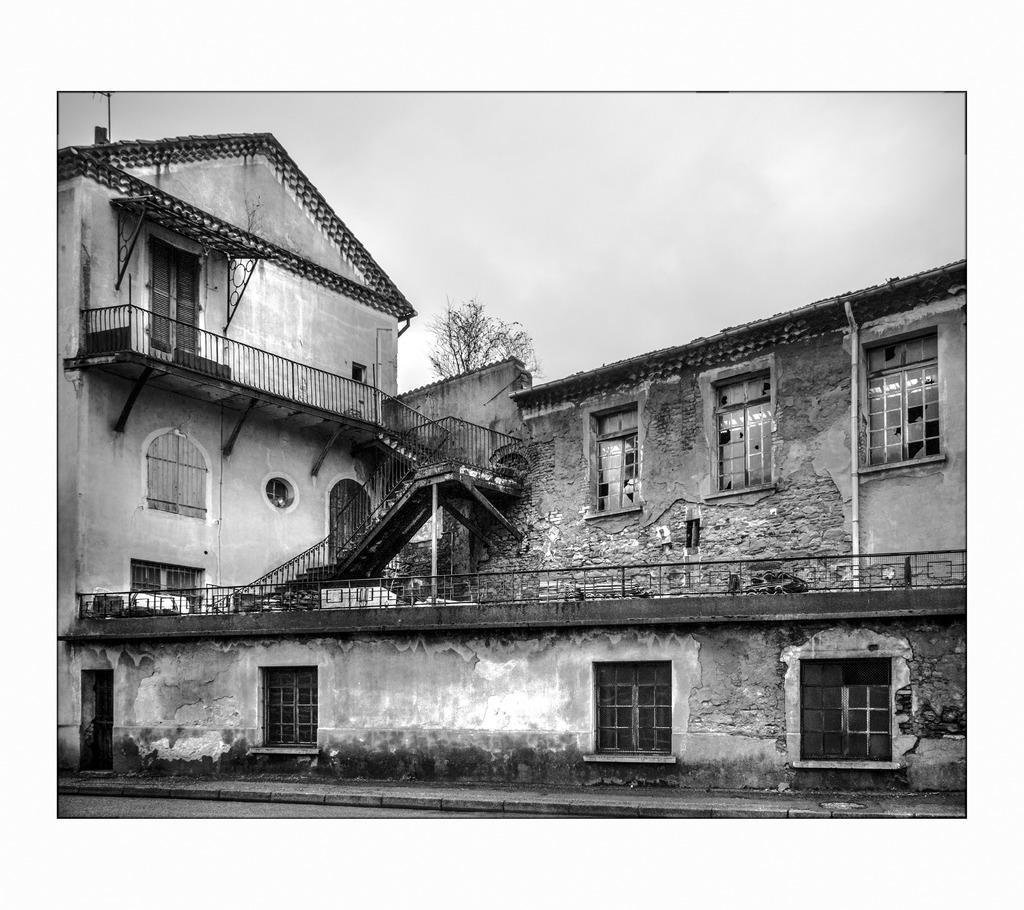What is the color scheme of the image? The image is black and white. What type of structure is present in the image? There is a building in the image. What features can be observed on the building? The building has windows and doors. What other objects are visible in the image? There is a fence and a tree in the image. What can be seen in the background of the image? The sky is visible in the background of the image. What type of blood vessels can be seen in the image? There is no reference to blood vessels or any biological elements in the image; it features a building, a fence, a tree, and the sky. 